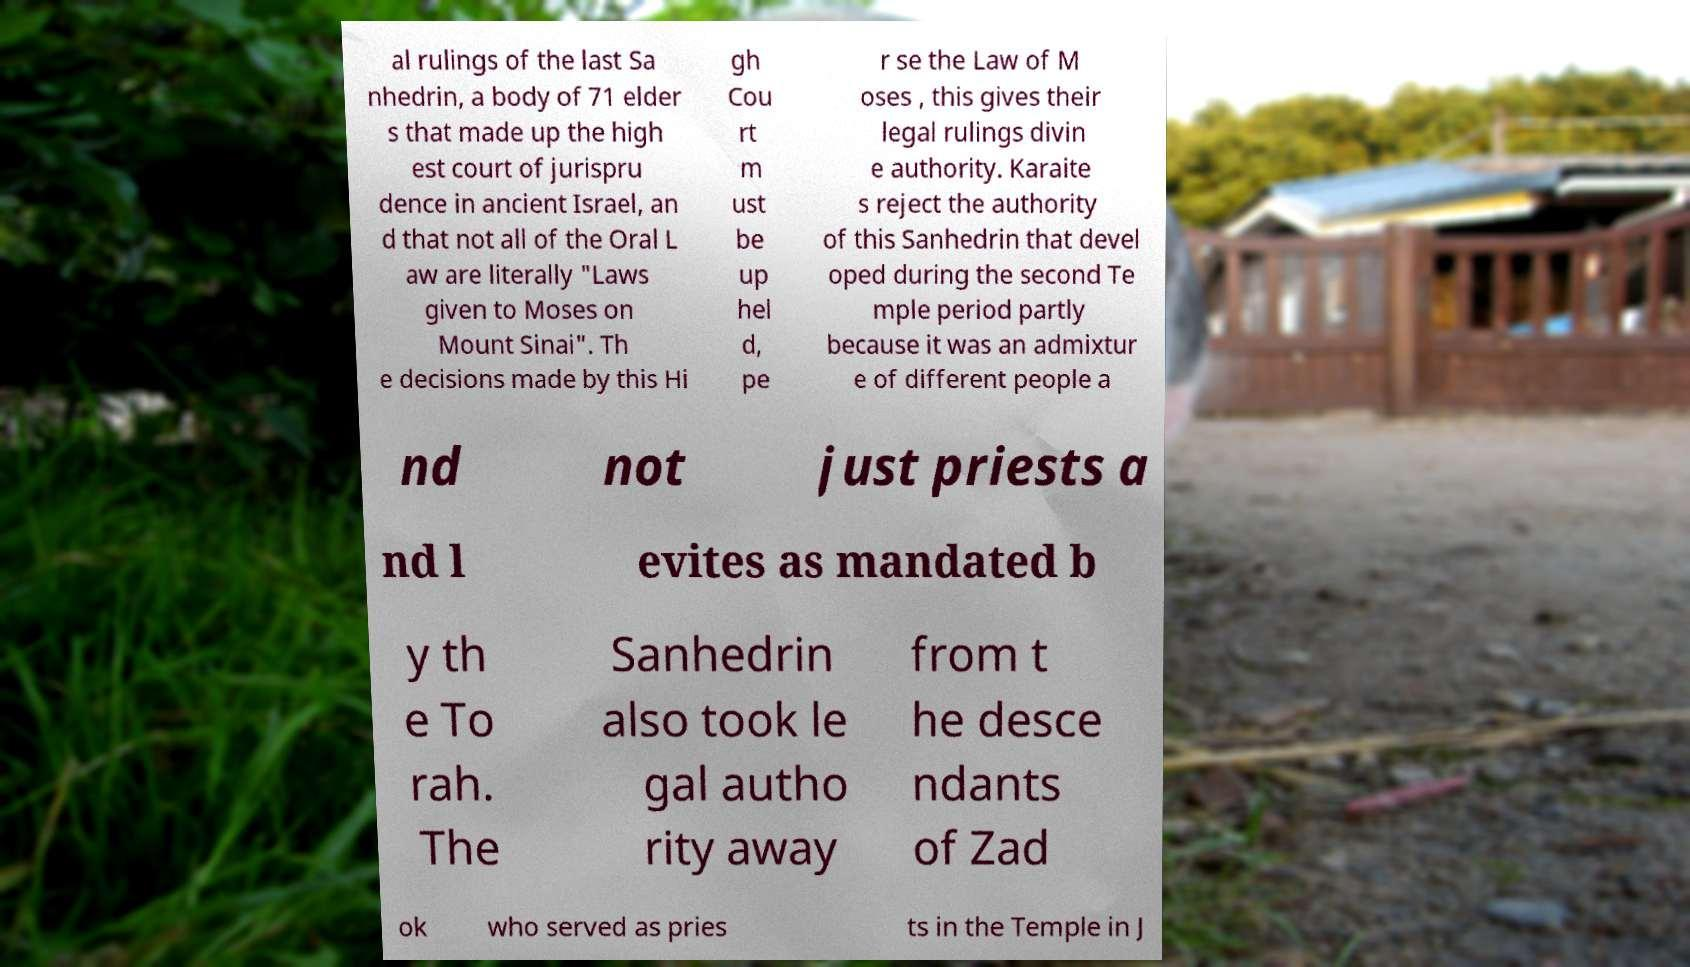Can you read and provide the text displayed in the image?This photo seems to have some interesting text. Can you extract and type it out for me? al rulings of the last Sa nhedrin, a body of 71 elder s that made up the high est court of jurispru dence in ancient Israel, an d that not all of the Oral L aw are literally "Laws given to Moses on Mount Sinai". Th e decisions made by this Hi gh Cou rt m ust be up hel d, pe r se the Law of M oses , this gives their legal rulings divin e authority. Karaite s reject the authority of this Sanhedrin that devel oped during the second Te mple period partly because it was an admixtur e of different people a nd not just priests a nd l evites as mandated b y th e To rah. The Sanhedrin also took le gal autho rity away from t he desce ndants of Zad ok who served as pries ts in the Temple in J 